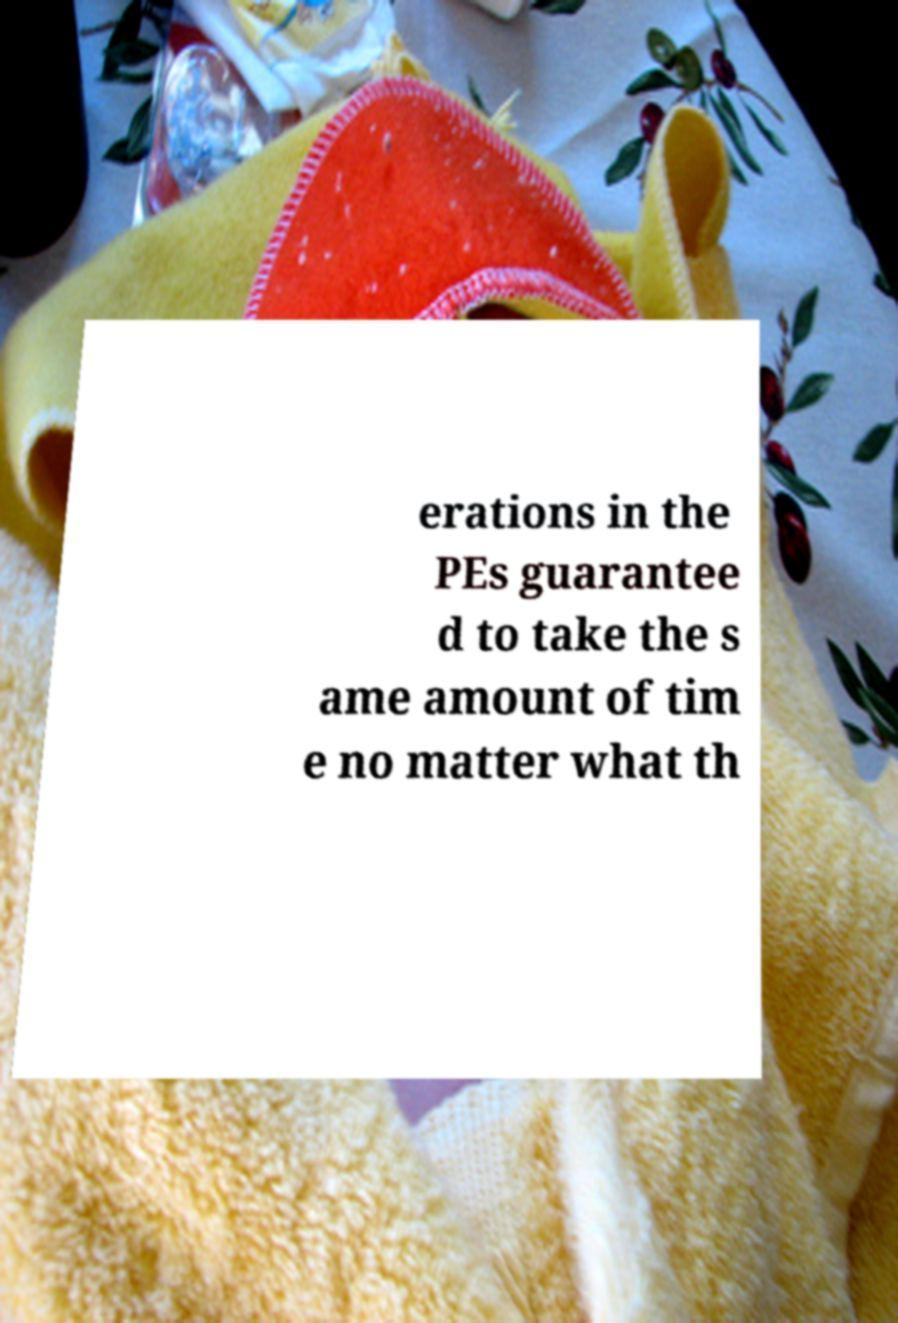Could you extract and type out the text from this image? erations in the PEs guarantee d to take the s ame amount of tim e no matter what th 